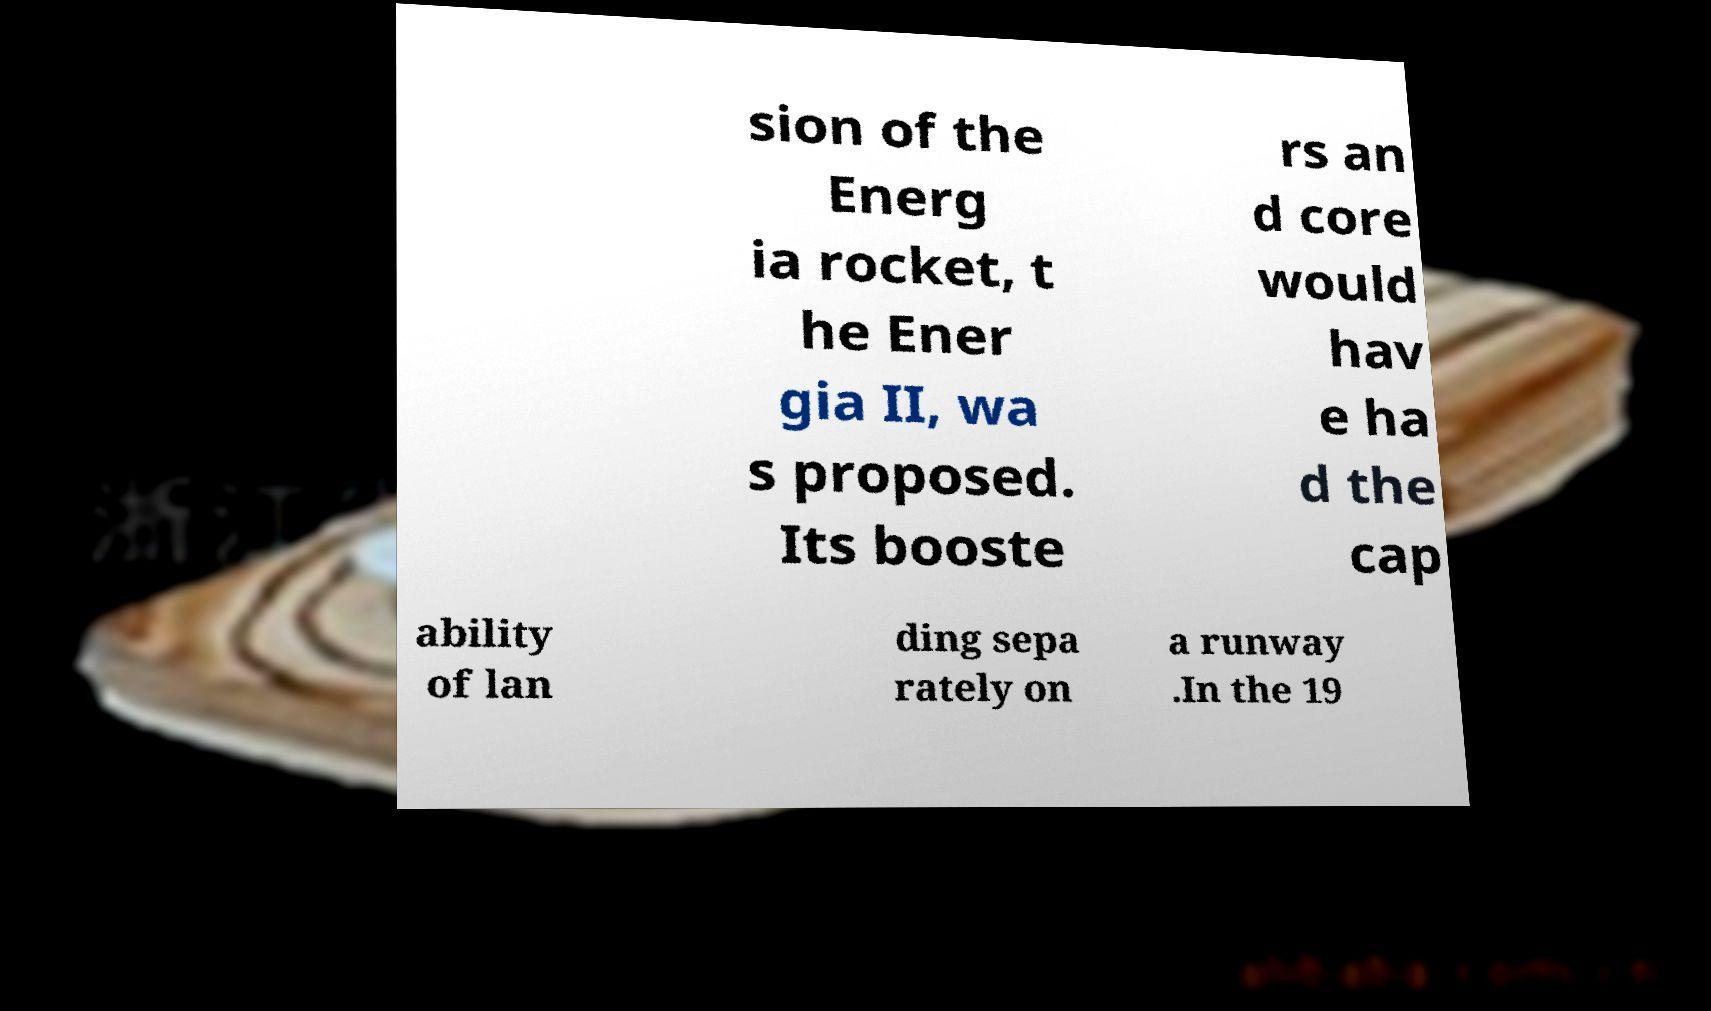What messages or text are displayed in this image? I need them in a readable, typed format. sion of the Energ ia rocket, t he Ener gia II, wa s proposed. Its booste rs an d core would hav e ha d the cap ability of lan ding sepa rately on a runway .In the 19 